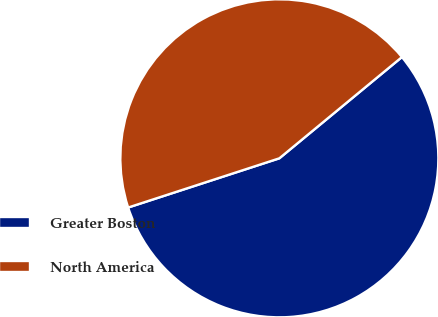<chart> <loc_0><loc_0><loc_500><loc_500><pie_chart><fcel>Greater Boston<fcel>North America<nl><fcel>55.98%<fcel>44.02%<nl></chart> 